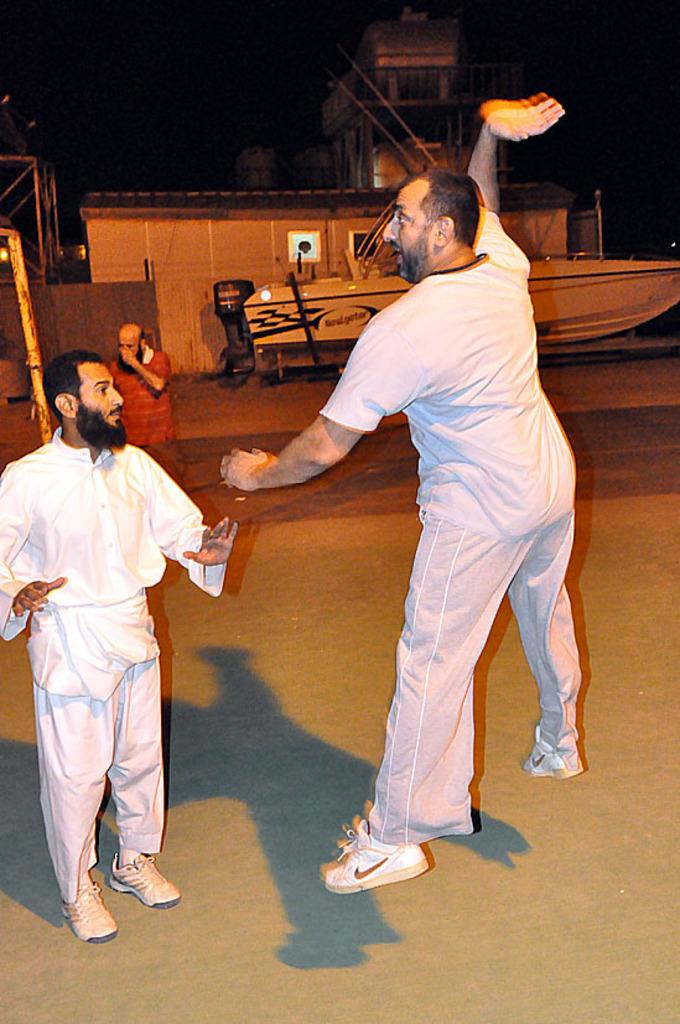How many people are in the image? There is a group of people in the image, but the exact number cannot be determined from the provided facts. What can be seen in the background of the image? There are metal rods, a boat, and buildings in the background of the image. What type of stew is being prepared by the people in the image? There is no indication in the image that the people are preparing or eating any stew, so it cannot be determined from the picture. 